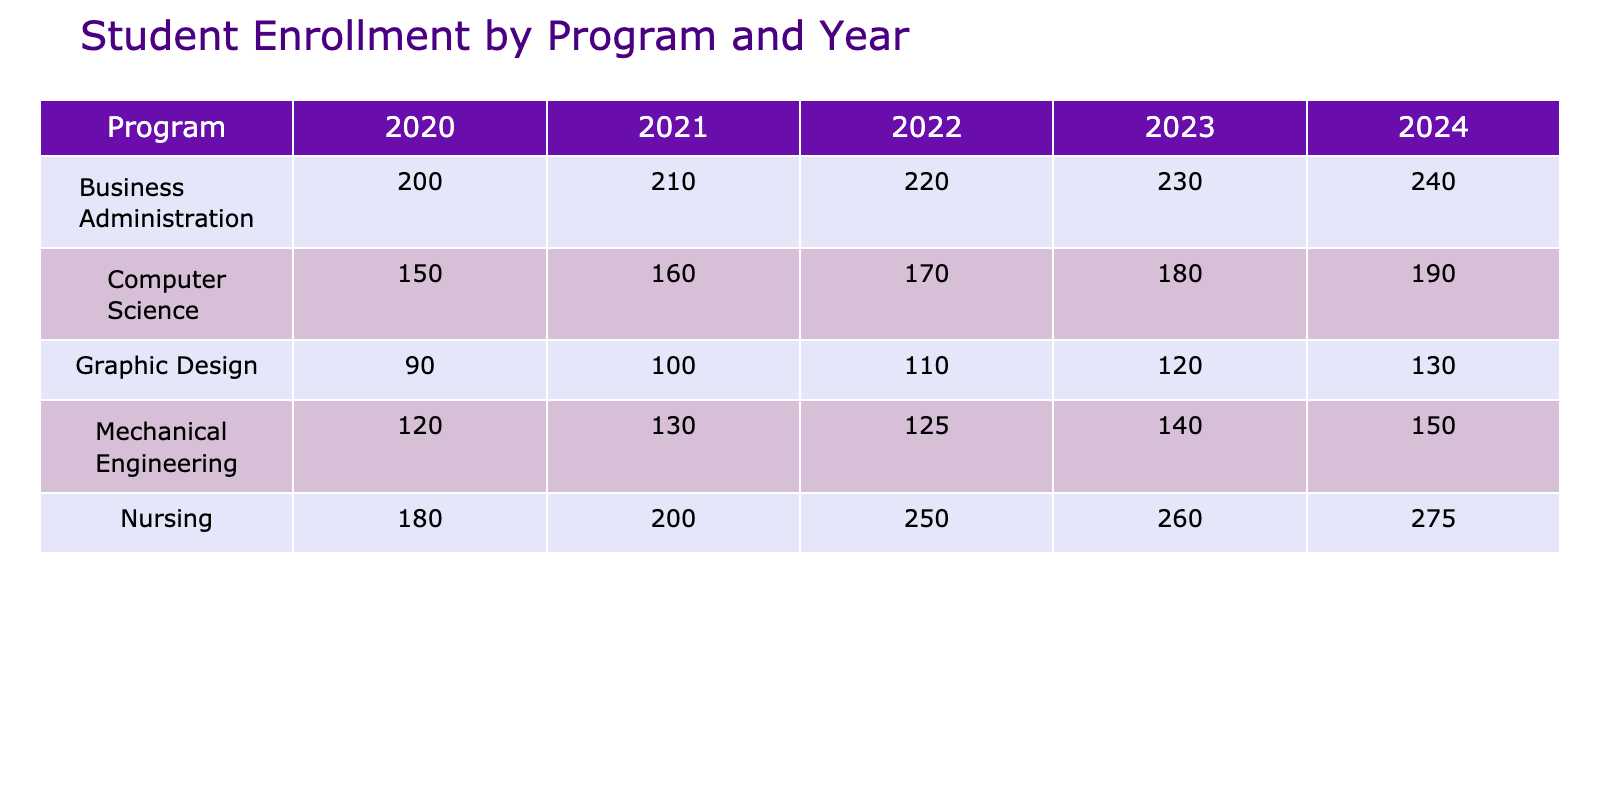What was the enrollment number for Nursing in 2021? The table shows the enrollment numbers by year and program. For Nursing in 2021, the enrollment figure is specifically provided in the row labeled "Nursing" under the year "2021". The number is 200.
Answer: 200 Which program had the highest enrollment in 2023? Looking at the year 2023, the table lists the enrollment figures for each program. By comparing these values, "Nursing" has the highest enrollment at 260.
Answer: Nursing What is the total enrollment for Business Administration from 2020 to 2024? To find the total enrollment for Business Administration, we sum the figures for each year: 200 (2020) + 210 (2021) + 220 (2022) + 230 (2023) + 240 (2024) = 1,110.
Answer: 1110 Did the enrollment for Mechanical Engineering decrease from 2021 to 2022? The enrollment for Mechanical Engineering in 2021 is 130, while in 2022 it is 125. Since 125 is less than 130, the enrollment indeed decreased.
Answer: Yes What is the percentage increase in enrollment for Computer Science from 2022 to 2024? The enrollment for Computer Science in 2022 is 170 and in 2024 is 190. The increase is 190 - 170 = 20. To find the percentage increase: (20 / 170) * 100 = 11.76%.
Answer: 11.76% Which program had the largest increase in enrollment from 2020 to 2024? Analyzing the enrollment figures from 2020 to 2024 for each program, we find: Computer Science increased from 150 to 190 (40), Business Administration from 200 to 240 (40), Mechanical Engineering from 120 to 150 (30), Nursing from 180 to 275 (95), and Graphic Design from 90 to 130 (40). Nursing had the largest increase with 95.
Answer: Nursing What is the average enrollment across all programs for the year 2022? The enrollments for 2022 are: Computer Science (170), Business Administration (220), Mechanical Engineering (125), Nursing (250), and Graphic Design (110). Their sum is 170 + 220 + 125 + 250 + 110 = 875. The average is 875 / 5 = 175.
Answer: 175 Was there ever a year when Graphic Design had higher enrollment than Mechanical Engineering? In comparing the enrollment figures, Graphic Design: 90 (2020), 100 (2021), 110 (2022), 120 (2023), 130 (2024) and Mechanical Engineering: 120 (2020), 130 (2021), 125 (2022), 140 (2023), 150 (2024). Graphic Design only surpassed Mechanical Engineering in the years 2023 and 2024.
Answer: Yes How much more did Nursing enroll compared to Graphic Design in 2023? The enrollment for Nursing in 2023 is 260 and for Graphic Design is 120. The difference is 260 - 120 = 140.
Answer: 140 In which year did Business Administration see its highest enrollment? By reviewing the enrollment data for Business Administration across the years, the figures are as follows: 200 (2020), 210 (2021), 220 (2022), 230 (2023), and 240 (2024). The maximum enrollment is in 2024 at 240.
Answer: 2024 